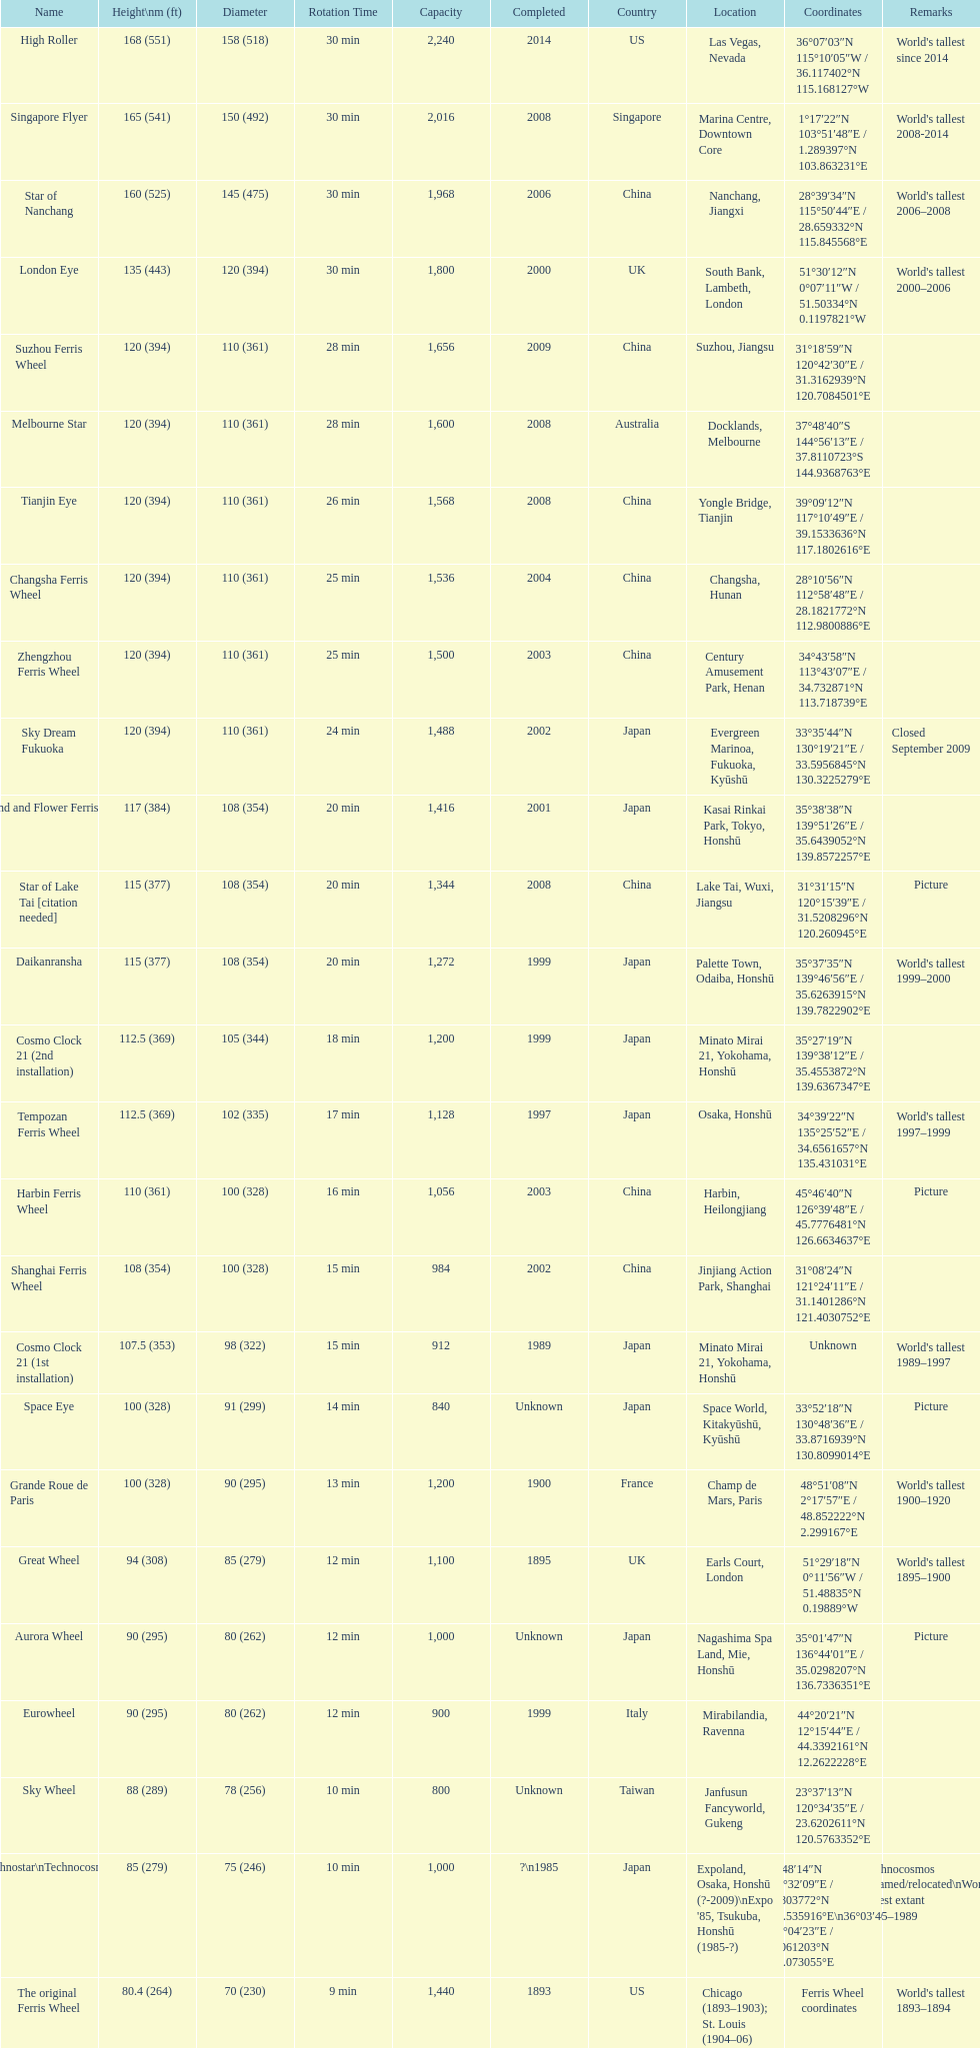Which ferris wheel was completed in 2008 and has the height of 165? Singapore Flyer. 